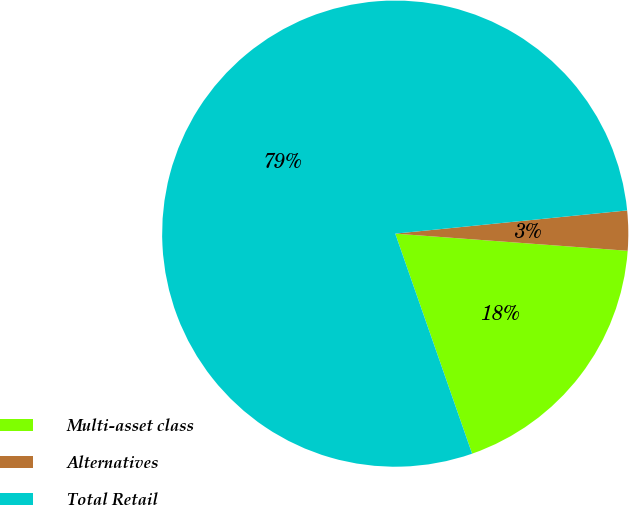<chart> <loc_0><loc_0><loc_500><loc_500><pie_chart><fcel>Multi-asset class<fcel>Alternatives<fcel>Total Retail<nl><fcel>18.48%<fcel>2.76%<fcel>78.76%<nl></chart> 